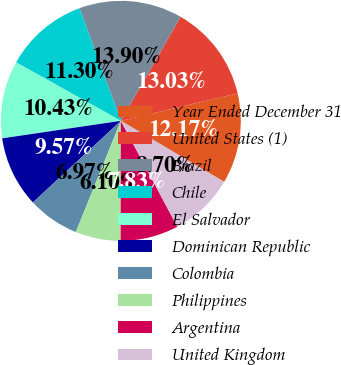Convert chart. <chart><loc_0><loc_0><loc_500><loc_500><pie_chart><fcel>Year Ended December 31<fcel>United States (1)<fcel>Brazil<fcel>Chile<fcel>El Salvador<fcel>Dominican Republic<fcel>Colombia<fcel>Philippines<fcel>Argentina<fcel>United Kingdom<nl><fcel>12.17%<fcel>13.03%<fcel>13.9%<fcel>11.3%<fcel>10.43%<fcel>9.57%<fcel>6.97%<fcel>6.1%<fcel>7.83%<fcel>8.7%<nl></chart> 